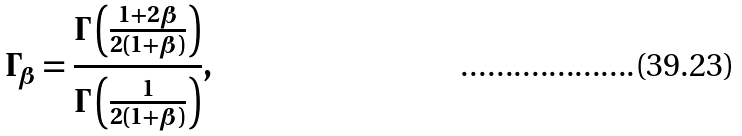Convert formula to latex. <formula><loc_0><loc_0><loc_500><loc_500>\Gamma _ { \beta } = \frac { \Gamma \left ( \frac { 1 + 2 \beta } { 2 ( 1 + \beta ) } \right ) } { \Gamma \left ( \frac { 1 } { 2 ( 1 + \beta ) } \right ) } ,</formula> 